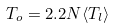<formula> <loc_0><loc_0><loc_500><loc_500>T _ { o } = 2 . 2 N \langle T _ { l } \rangle</formula> 